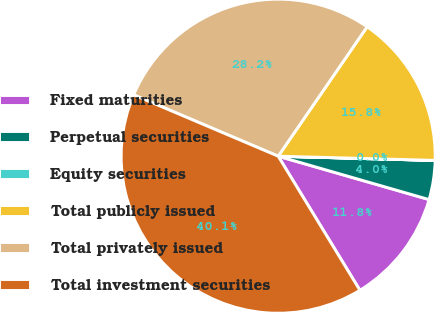Convert chart to OTSL. <chart><loc_0><loc_0><loc_500><loc_500><pie_chart><fcel>Fixed maturities<fcel>Perpetual securities<fcel>Equity securities<fcel>Total publicly issued<fcel>Total privately issued<fcel>Total investment securities<nl><fcel>11.83%<fcel>4.02%<fcel>0.01%<fcel>15.84%<fcel>28.19%<fcel>40.1%<nl></chart> 